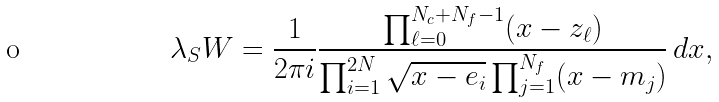<formula> <loc_0><loc_0><loc_500><loc_500>\lambda _ { S } W = \frac { 1 } { 2 \pi i } \frac { \prod _ { \ell = 0 } ^ { N _ { c } + N _ { f } - 1 } ( x - z _ { \ell } ) } { \prod _ { i = 1 } ^ { 2 N } \sqrt { x - e _ { i } } \prod _ { j = 1 } ^ { N _ { f } } ( x - m _ { j } ) } \, d x ,</formula> 